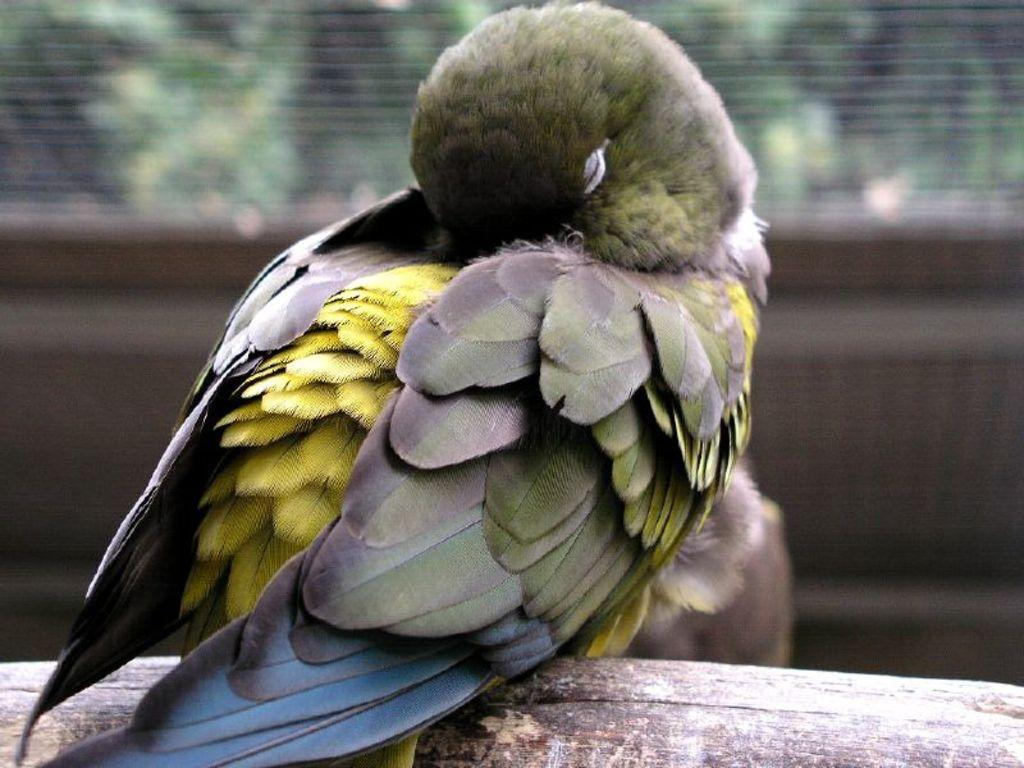What type of animal is in the image? There is a bird in the image. Where is the bird located? The bird is on a wooden surface. Can you describe the background of the image? The background of the image is blurred. What type of government is depicted in the image? There is no government depicted in the image; it features a bird on a wooden surface with a blurred background. How many rings are visible in the image? There are no rings present in the image. 